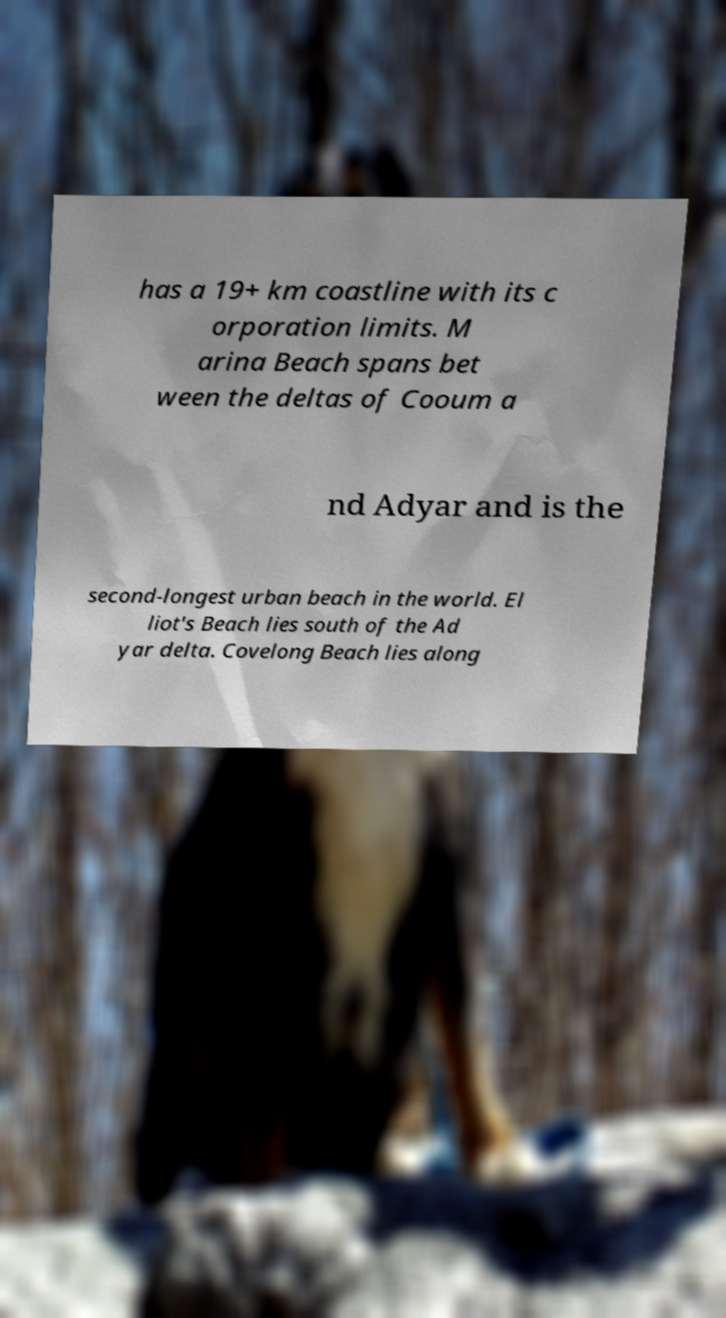What messages or text are displayed in this image? I need them in a readable, typed format. has a 19+ km coastline with its c orporation limits. M arina Beach spans bet ween the deltas of Cooum a nd Adyar and is the second-longest urban beach in the world. El liot's Beach lies south of the Ad yar delta. Covelong Beach lies along 